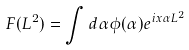Convert formula to latex. <formula><loc_0><loc_0><loc_500><loc_500>F ( { L ^ { 2 } } ) = \int d \alpha \phi ( \alpha ) e ^ { i x \alpha { L ^ { 2 } } }</formula> 